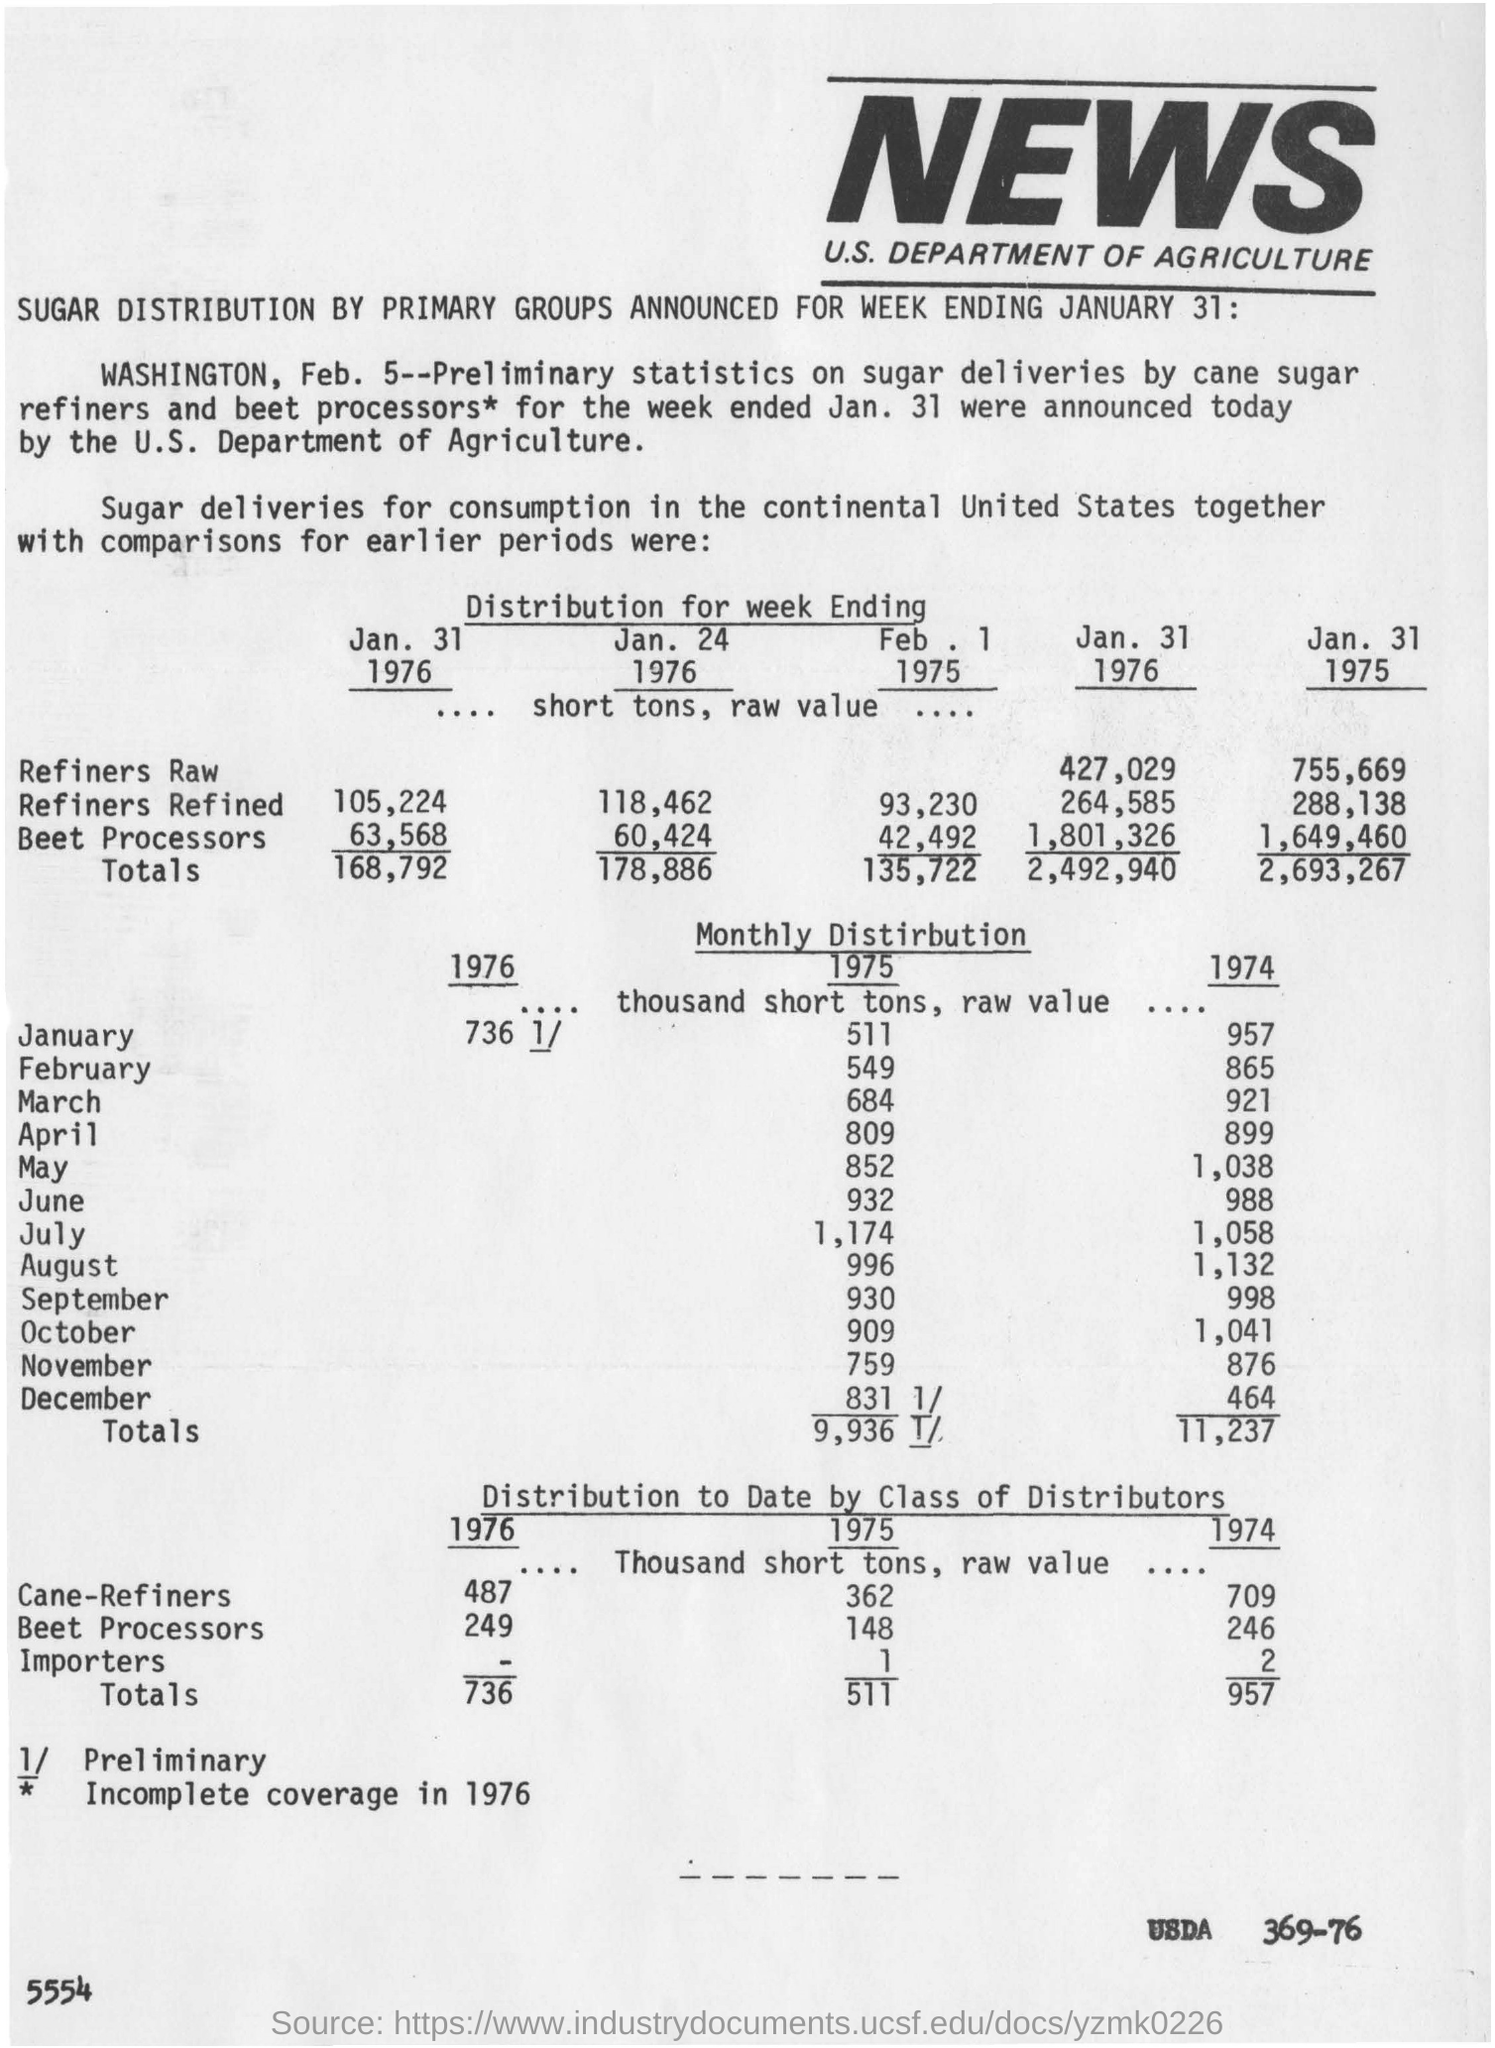Outline some significant characteristics in this image. The U.S. Department of Agriculture announced the preliminary statistics on sugar deliveries by cane sugar refiners and beet processors. 